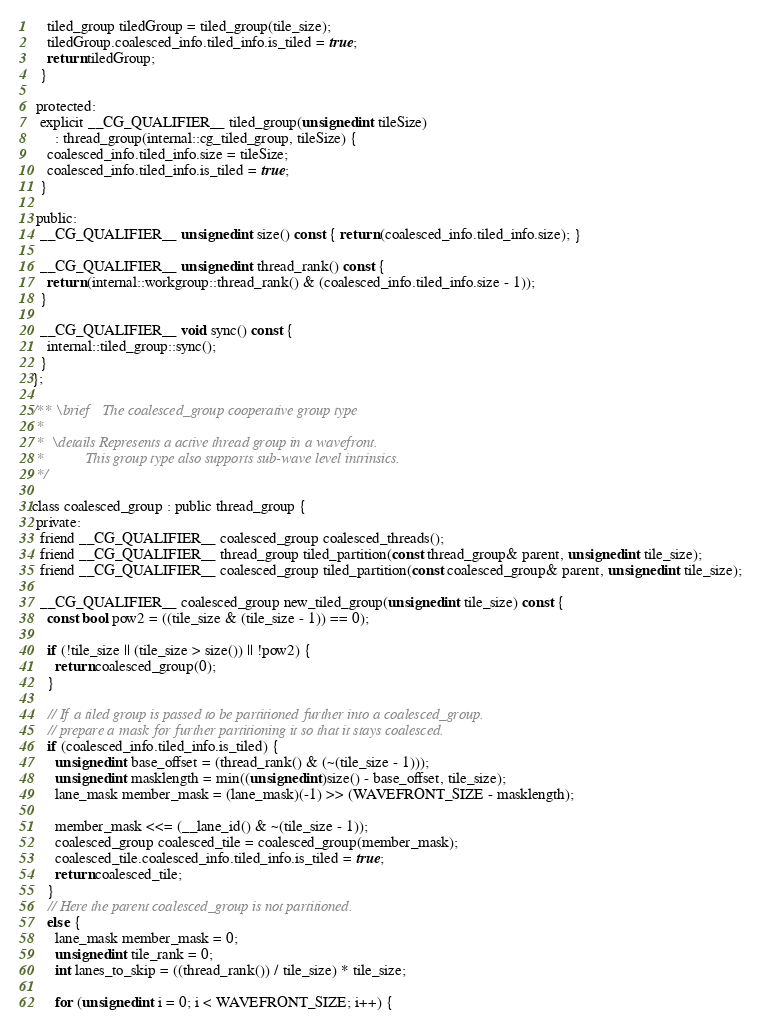Convert code to text. <code><loc_0><loc_0><loc_500><loc_500><_C_>
    tiled_group tiledGroup = tiled_group(tile_size);
    tiledGroup.coalesced_info.tiled_info.is_tiled = true;
    return tiledGroup;
  }

 protected:
  explicit __CG_QUALIFIER__ tiled_group(unsigned int tileSize)
      : thread_group(internal::cg_tiled_group, tileSize) {
    coalesced_info.tiled_info.size = tileSize;
    coalesced_info.tiled_info.is_tiled = true;
  }

 public:
  __CG_QUALIFIER__ unsigned int size() const { return (coalesced_info.tiled_info.size); }

  __CG_QUALIFIER__ unsigned int thread_rank() const {
    return (internal::workgroup::thread_rank() & (coalesced_info.tiled_info.size - 1));
  }

  __CG_QUALIFIER__ void sync() const {
    internal::tiled_group::sync();
  }
};

/** \brief   The coalesced_group cooperative group type
 *
 *  \details Represents a active thread group in a wavefront.
 *           This group type also supports sub-wave level intrinsics.
 */

class coalesced_group : public thread_group {
 private:
  friend __CG_QUALIFIER__ coalesced_group coalesced_threads();
  friend __CG_QUALIFIER__ thread_group tiled_partition(const thread_group& parent, unsigned int tile_size);
  friend __CG_QUALIFIER__ coalesced_group tiled_partition(const coalesced_group& parent, unsigned int tile_size);

  __CG_QUALIFIER__ coalesced_group new_tiled_group(unsigned int tile_size) const {
    const bool pow2 = ((tile_size & (tile_size - 1)) == 0);

    if (!tile_size || (tile_size > size()) || !pow2) {
      return coalesced_group(0);
    }

    // If a tiled group is passed to be partitioned further into a coalesced_group.
    // prepare a mask for further partitioning it so that it stays coalesced.
    if (coalesced_info.tiled_info.is_tiled) {
      unsigned int base_offset = (thread_rank() & (~(tile_size - 1)));
      unsigned int masklength = min((unsigned int)size() - base_offset, tile_size);
      lane_mask member_mask = (lane_mask)(-1) >> (WAVEFRONT_SIZE - masklength);

      member_mask <<= (__lane_id() & ~(tile_size - 1));
      coalesced_group coalesced_tile = coalesced_group(member_mask);
      coalesced_tile.coalesced_info.tiled_info.is_tiled = true;
      return coalesced_tile;
    }
    // Here the parent coalesced_group is not partitioned.
    else {
      lane_mask member_mask = 0;
      unsigned int tile_rank = 0;
      int lanes_to_skip = ((thread_rank()) / tile_size) * tile_size;

      for (unsigned int i = 0; i < WAVEFRONT_SIZE; i++) {</code> 